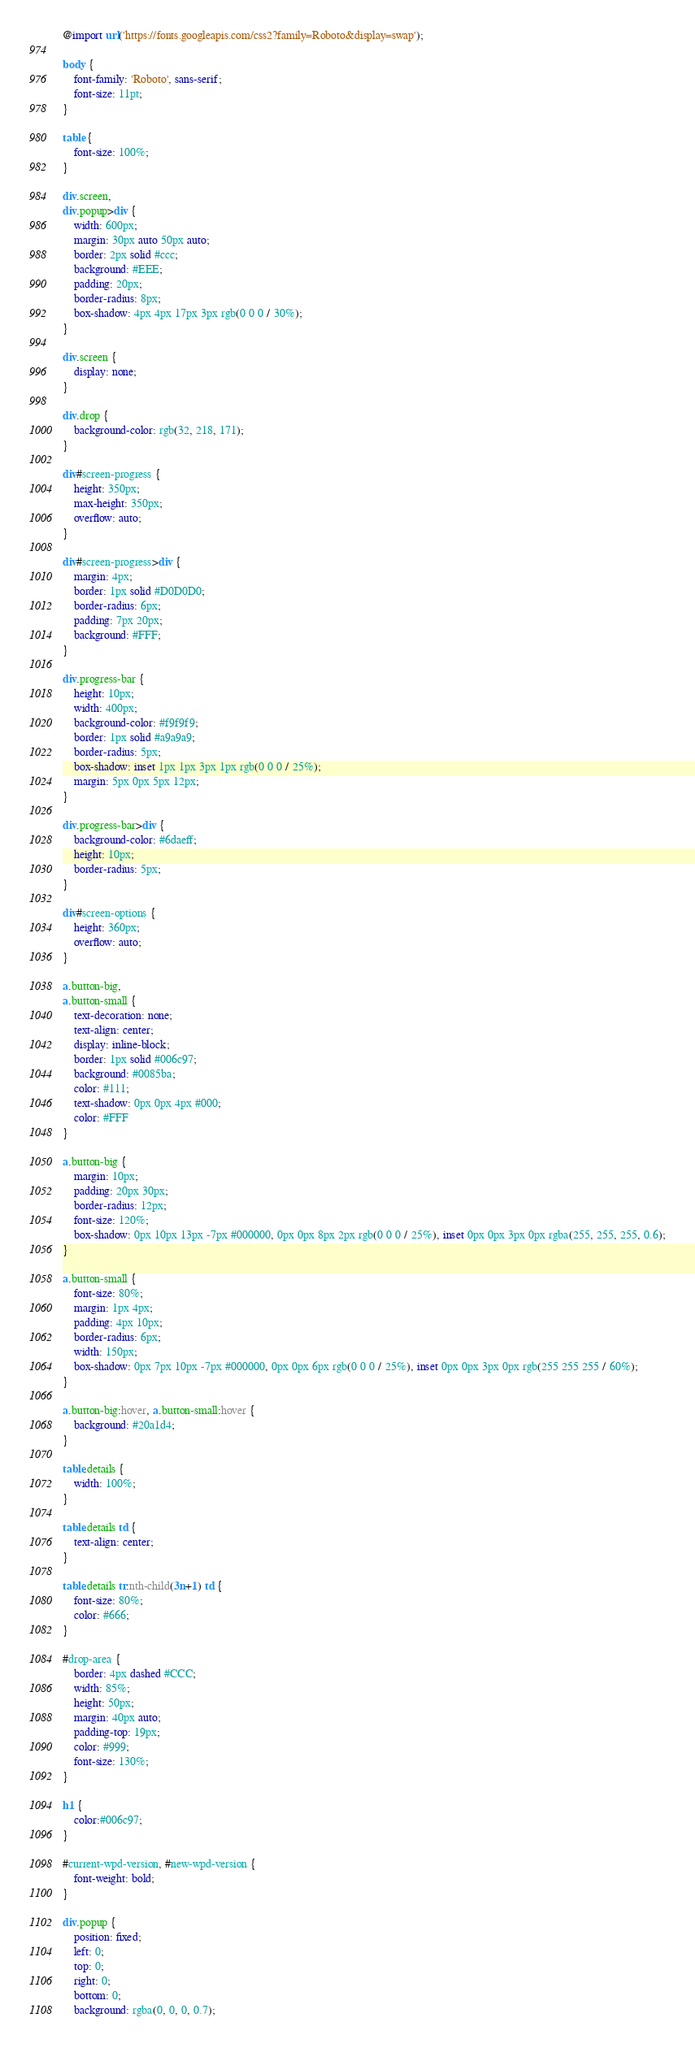<code> <loc_0><loc_0><loc_500><loc_500><_CSS_>
@import url('https://fonts.googleapis.com/css2?family=Roboto&display=swap');

body {
    font-family: 'Roboto', sans-serif;
    font-size: 11pt;
}

table {
    font-size: 100%;
}

div.screen,
div.popup>div {
    width: 600px;
    margin: 30px auto 50px auto;
    border: 2px solid #ccc;
    background: #EEE;
    padding: 20px;
    border-radius: 8px;
    box-shadow: 4px 4px 17px 3px rgb(0 0 0 / 30%);
}

div.screen {
    display: none;
}

div.drop {
    background-color: rgb(32, 218, 171);
}

div#screen-progress {
    height: 350px;
    max-height: 350px;
    overflow: auto;
}

div#screen-progress>div {
    margin: 4px;
    border: 1px solid #D0D0D0;
    border-radius: 6px;
    padding: 7px 20px;
    background: #FFF;
}

div.progress-bar {
    height: 10px;
    width: 400px;
    background-color: #f9f9f9;
    border: 1px solid #a9a9a9;
    border-radius: 5px;
    box-shadow: inset 1px 1px 3px 1px rgb(0 0 0 / 25%);
    margin: 5px 0px 5px 12px;
}

div.progress-bar>div {
    background-color: #6daeff;
    height: 10px;
    border-radius: 5px;
}

div#screen-options {
    height: 360px;
    overflow: auto;
}

a.button-big,
a.button-small {
    text-decoration: none;
    text-align: center;
    display: inline-block;
    border: 1px solid #006c97;
    background: #0085ba;
    color: #111;
    text-shadow: 0px 0px 4px #000;
    color: #FFF
}

a.button-big {
    margin: 10px;
    padding: 20px 30px;
    border-radius: 12px;
    font-size: 120%;
    box-shadow: 0px 10px 13px -7px #000000, 0px 0px 8px 2px rgb(0 0 0 / 25%), inset 0px 0px 3px 0px rgba(255, 255, 255, 0.6);
}

a.button-small {
    font-size: 80%;
    margin: 1px 4px;
    padding: 4px 10px;
    border-radius: 6px;
    width: 150px;
    box-shadow: 0px 7px 10px -7px #000000, 0px 0px 6px rgb(0 0 0 / 25%), inset 0px 0px 3px 0px rgb(255 255 255 / 60%);
}

a.button-big:hover, a.button-small:hover {
    background: #20a1d4;
}

table.details {
    width: 100%;
}

table.details td {
    text-align: center;
}

table.details tr:nth-child(3n+1) td {
    font-size: 80%;
    color: #666;
}

#drop-area {
    border: 4px dashed #CCC;
    width: 85%;
    height: 50px;
    margin: 40px auto;
    padding-top: 19px;
    color: #999;
    font-size: 130%;
}

h1 {
    color:#006c97;
}

#current-wpd-version, #new-wpd-version {
    font-weight: bold;
}

div.popup {
    position: fixed;
    left: 0;
    top: 0;
    right: 0;
    bottom: 0;
    background: rgba(0, 0, 0, 0.7);</code> 